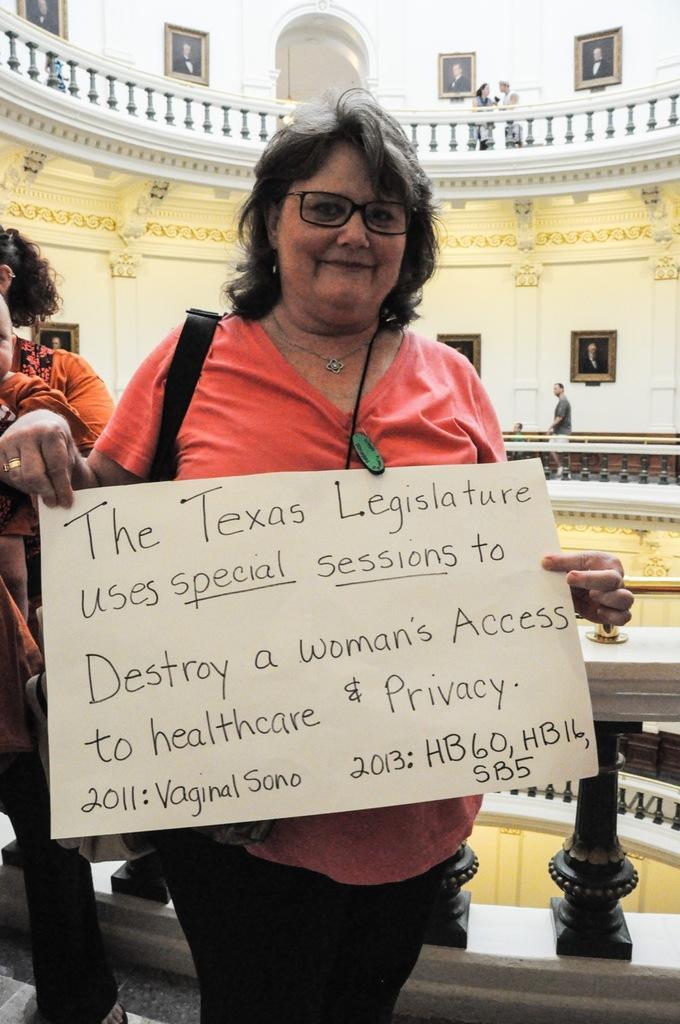Describe this image in one or two sentences. This image is taken indoors. In the background there are a few walls with picture frames and doors. There are a few railings. There are many carvings on the walls. There is a man standing on the floor. On the left side of the image a woman is standing and she is holding a baby in her hands. In the middle of the image a woman is standing and she is holding a board with a text on it. She is with a smiling face. 